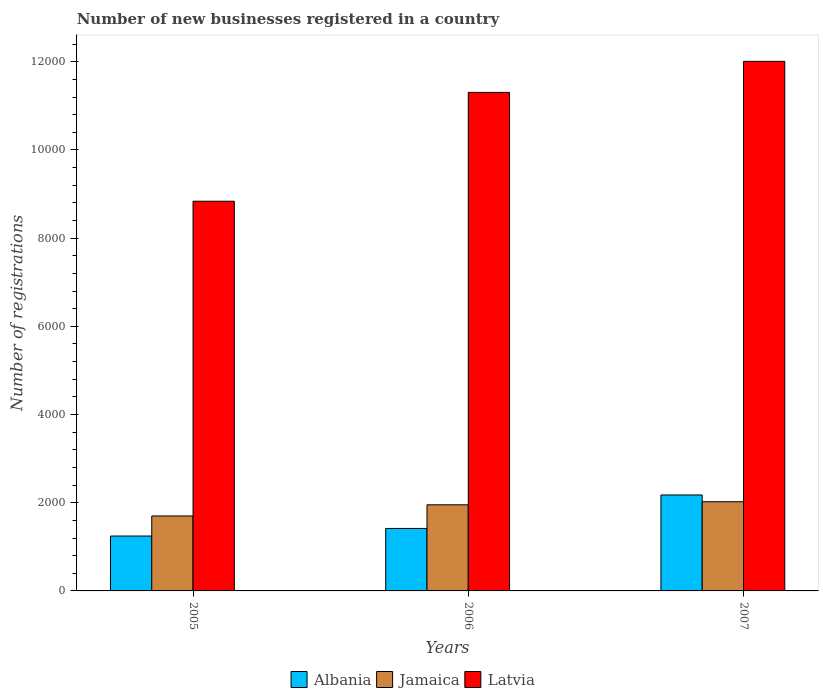How many groups of bars are there?
Your answer should be compact. 3. How many bars are there on the 2nd tick from the left?
Ensure brevity in your answer.  3. How many bars are there on the 3rd tick from the right?
Keep it short and to the point. 3. What is the number of new businesses registered in Jamaica in 2007?
Offer a very short reply. 2023. Across all years, what is the maximum number of new businesses registered in Latvia?
Ensure brevity in your answer.  1.20e+04. Across all years, what is the minimum number of new businesses registered in Latvia?
Your answer should be very brief. 8838. What is the total number of new businesses registered in Jamaica in the graph?
Provide a succinct answer. 5676. What is the difference between the number of new businesses registered in Jamaica in 2006 and that in 2007?
Your answer should be compact. -70. What is the difference between the number of new businesses registered in Jamaica in 2005 and the number of new businesses registered in Latvia in 2006?
Give a very brief answer. -9606. What is the average number of new businesses registered in Albania per year?
Make the answer very short. 1612.67. In the year 2007, what is the difference between the number of new businesses registered in Jamaica and number of new businesses registered in Latvia?
Give a very brief answer. -9987. In how many years, is the number of new businesses registered in Latvia greater than 1200?
Make the answer very short. 3. What is the ratio of the number of new businesses registered in Albania in 2005 to that in 2006?
Ensure brevity in your answer.  0.88. Is the number of new businesses registered in Jamaica in 2005 less than that in 2007?
Provide a short and direct response. Yes. Is the difference between the number of new businesses registered in Jamaica in 2005 and 2006 greater than the difference between the number of new businesses registered in Latvia in 2005 and 2006?
Make the answer very short. Yes. What is the difference between the highest and the second highest number of new businesses registered in Albania?
Your answer should be compact. 759. What is the difference between the highest and the lowest number of new businesses registered in Jamaica?
Provide a succinct answer. 323. In how many years, is the number of new businesses registered in Jamaica greater than the average number of new businesses registered in Jamaica taken over all years?
Offer a very short reply. 2. What does the 2nd bar from the left in 2006 represents?
Your answer should be compact. Jamaica. What does the 1st bar from the right in 2007 represents?
Give a very brief answer. Latvia. How many bars are there?
Provide a succinct answer. 9. How many years are there in the graph?
Provide a succinct answer. 3. What is the difference between two consecutive major ticks on the Y-axis?
Your response must be concise. 2000. Are the values on the major ticks of Y-axis written in scientific E-notation?
Your answer should be compact. No. How are the legend labels stacked?
Make the answer very short. Horizontal. What is the title of the graph?
Make the answer very short. Number of new businesses registered in a country. What is the label or title of the Y-axis?
Make the answer very short. Number of registrations. What is the Number of registrations of Albania in 2005?
Ensure brevity in your answer.  1245. What is the Number of registrations in Jamaica in 2005?
Your answer should be very brief. 1700. What is the Number of registrations in Latvia in 2005?
Your answer should be very brief. 8838. What is the Number of registrations of Albania in 2006?
Ensure brevity in your answer.  1417. What is the Number of registrations in Jamaica in 2006?
Make the answer very short. 1953. What is the Number of registrations of Latvia in 2006?
Keep it short and to the point. 1.13e+04. What is the Number of registrations of Albania in 2007?
Ensure brevity in your answer.  2176. What is the Number of registrations in Jamaica in 2007?
Provide a succinct answer. 2023. What is the Number of registrations in Latvia in 2007?
Your response must be concise. 1.20e+04. Across all years, what is the maximum Number of registrations in Albania?
Provide a short and direct response. 2176. Across all years, what is the maximum Number of registrations in Jamaica?
Offer a terse response. 2023. Across all years, what is the maximum Number of registrations of Latvia?
Ensure brevity in your answer.  1.20e+04. Across all years, what is the minimum Number of registrations of Albania?
Provide a succinct answer. 1245. Across all years, what is the minimum Number of registrations in Jamaica?
Offer a terse response. 1700. Across all years, what is the minimum Number of registrations in Latvia?
Your response must be concise. 8838. What is the total Number of registrations in Albania in the graph?
Offer a terse response. 4838. What is the total Number of registrations in Jamaica in the graph?
Give a very brief answer. 5676. What is the total Number of registrations in Latvia in the graph?
Your answer should be compact. 3.22e+04. What is the difference between the Number of registrations in Albania in 2005 and that in 2006?
Offer a very short reply. -172. What is the difference between the Number of registrations of Jamaica in 2005 and that in 2006?
Keep it short and to the point. -253. What is the difference between the Number of registrations of Latvia in 2005 and that in 2006?
Your answer should be very brief. -2468. What is the difference between the Number of registrations of Albania in 2005 and that in 2007?
Offer a very short reply. -931. What is the difference between the Number of registrations of Jamaica in 2005 and that in 2007?
Make the answer very short. -323. What is the difference between the Number of registrations in Latvia in 2005 and that in 2007?
Your answer should be compact. -3172. What is the difference between the Number of registrations in Albania in 2006 and that in 2007?
Offer a terse response. -759. What is the difference between the Number of registrations of Jamaica in 2006 and that in 2007?
Make the answer very short. -70. What is the difference between the Number of registrations in Latvia in 2006 and that in 2007?
Make the answer very short. -704. What is the difference between the Number of registrations of Albania in 2005 and the Number of registrations of Jamaica in 2006?
Give a very brief answer. -708. What is the difference between the Number of registrations of Albania in 2005 and the Number of registrations of Latvia in 2006?
Your answer should be compact. -1.01e+04. What is the difference between the Number of registrations in Jamaica in 2005 and the Number of registrations in Latvia in 2006?
Your answer should be compact. -9606. What is the difference between the Number of registrations in Albania in 2005 and the Number of registrations in Jamaica in 2007?
Your answer should be compact. -778. What is the difference between the Number of registrations of Albania in 2005 and the Number of registrations of Latvia in 2007?
Your response must be concise. -1.08e+04. What is the difference between the Number of registrations of Jamaica in 2005 and the Number of registrations of Latvia in 2007?
Offer a very short reply. -1.03e+04. What is the difference between the Number of registrations of Albania in 2006 and the Number of registrations of Jamaica in 2007?
Your response must be concise. -606. What is the difference between the Number of registrations in Albania in 2006 and the Number of registrations in Latvia in 2007?
Your answer should be compact. -1.06e+04. What is the difference between the Number of registrations in Jamaica in 2006 and the Number of registrations in Latvia in 2007?
Offer a terse response. -1.01e+04. What is the average Number of registrations in Albania per year?
Keep it short and to the point. 1612.67. What is the average Number of registrations in Jamaica per year?
Your response must be concise. 1892. What is the average Number of registrations of Latvia per year?
Make the answer very short. 1.07e+04. In the year 2005, what is the difference between the Number of registrations in Albania and Number of registrations in Jamaica?
Your answer should be very brief. -455. In the year 2005, what is the difference between the Number of registrations in Albania and Number of registrations in Latvia?
Give a very brief answer. -7593. In the year 2005, what is the difference between the Number of registrations in Jamaica and Number of registrations in Latvia?
Offer a very short reply. -7138. In the year 2006, what is the difference between the Number of registrations of Albania and Number of registrations of Jamaica?
Ensure brevity in your answer.  -536. In the year 2006, what is the difference between the Number of registrations of Albania and Number of registrations of Latvia?
Give a very brief answer. -9889. In the year 2006, what is the difference between the Number of registrations in Jamaica and Number of registrations in Latvia?
Provide a short and direct response. -9353. In the year 2007, what is the difference between the Number of registrations in Albania and Number of registrations in Jamaica?
Your response must be concise. 153. In the year 2007, what is the difference between the Number of registrations in Albania and Number of registrations in Latvia?
Provide a succinct answer. -9834. In the year 2007, what is the difference between the Number of registrations of Jamaica and Number of registrations of Latvia?
Make the answer very short. -9987. What is the ratio of the Number of registrations in Albania in 2005 to that in 2006?
Ensure brevity in your answer.  0.88. What is the ratio of the Number of registrations in Jamaica in 2005 to that in 2006?
Your answer should be compact. 0.87. What is the ratio of the Number of registrations in Latvia in 2005 to that in 2006?
Offer a very short reply. 0.78. What is the ratio of the Number of registrations in Albania in 2005 to that in 2007?
Provide a short and direct response. 0.57. What is the ratio of the Number of registrations in Jamaica in 2005 to that in 2007?
Make the answer very short. 0.84. What is the ratio of the Number of registrations in Latvia in 2005 to that in 2007?
Your answer should be compact. 0.74. What is the ratio of the Number of registrations of Albania in 2006 to that in 2007?
Your answer should be compact. 0.65. What is the ratio of the Number of registrations in Jamaica in 2006 to that in 2007?
Your answer should be compact. 0.97. What is the ratio of the Number of registrations of Latvia in 2006 to that in 2007?
Offer a very short reply. 0.94. What is the difference between the highest and the second highest Number of registrations in Albania?
Offer a very short reply. 759. What is the difference between the highest and the second highest Number of registrations of Latvia?
Give a very brief answer. 704. What is the difference between the highest and the lowest Number of registrations of Albania?
Offer a very short reply. 931. What is the difference between the highest and the lowest Number of registrations of Jamaica?
Keep it short and to the point. 323. What is the difference between the highest and the lowest Number of registrations in Latvia?
Provide a succinct answer. 3172. 